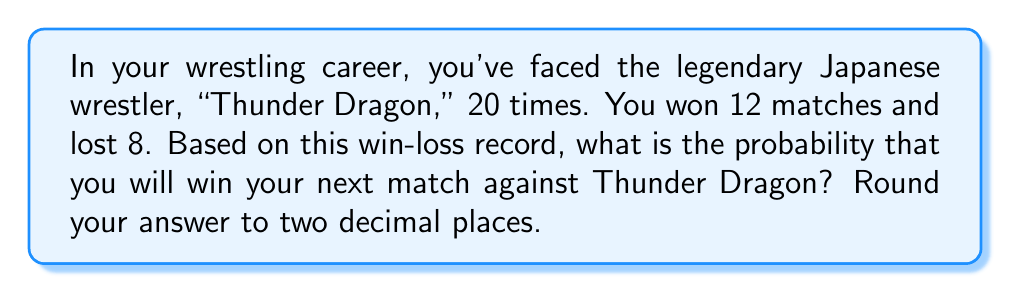Can you solve this math problem? To predict the probability of winning the next match based on past performance, we can use the concept of relative frequency as an estimate of probability.

Step 1: Calculate the total number of matches
Total matches = Wins + Losses = 12 + 8 = 20

Step 2: Calculate the win ratio
Win ratio = $\frac{\text{Number of wins}}{\text{Total matches}}$
Win ratio = $\frac{12}{20}$ = 0.6

Step 3: Convert the win ratio to a percentage
Probability of winning = Win ratio × 100%
Probability of winning = 0.6 × 100% = 60%

Step 4: Round to two decimal places
60% = 0.60

Therefore, based on your past performance against Thunder Dragon, the probability of winning your next match is 0.60 or 60%.

It's important to note that this is a simplified model and doesn't account for other factors such as current form, injuries, or changes in skill level over time. In reality, predicting match outcomes is more complex and would involve considering additional variables.
Answer: 0.60 